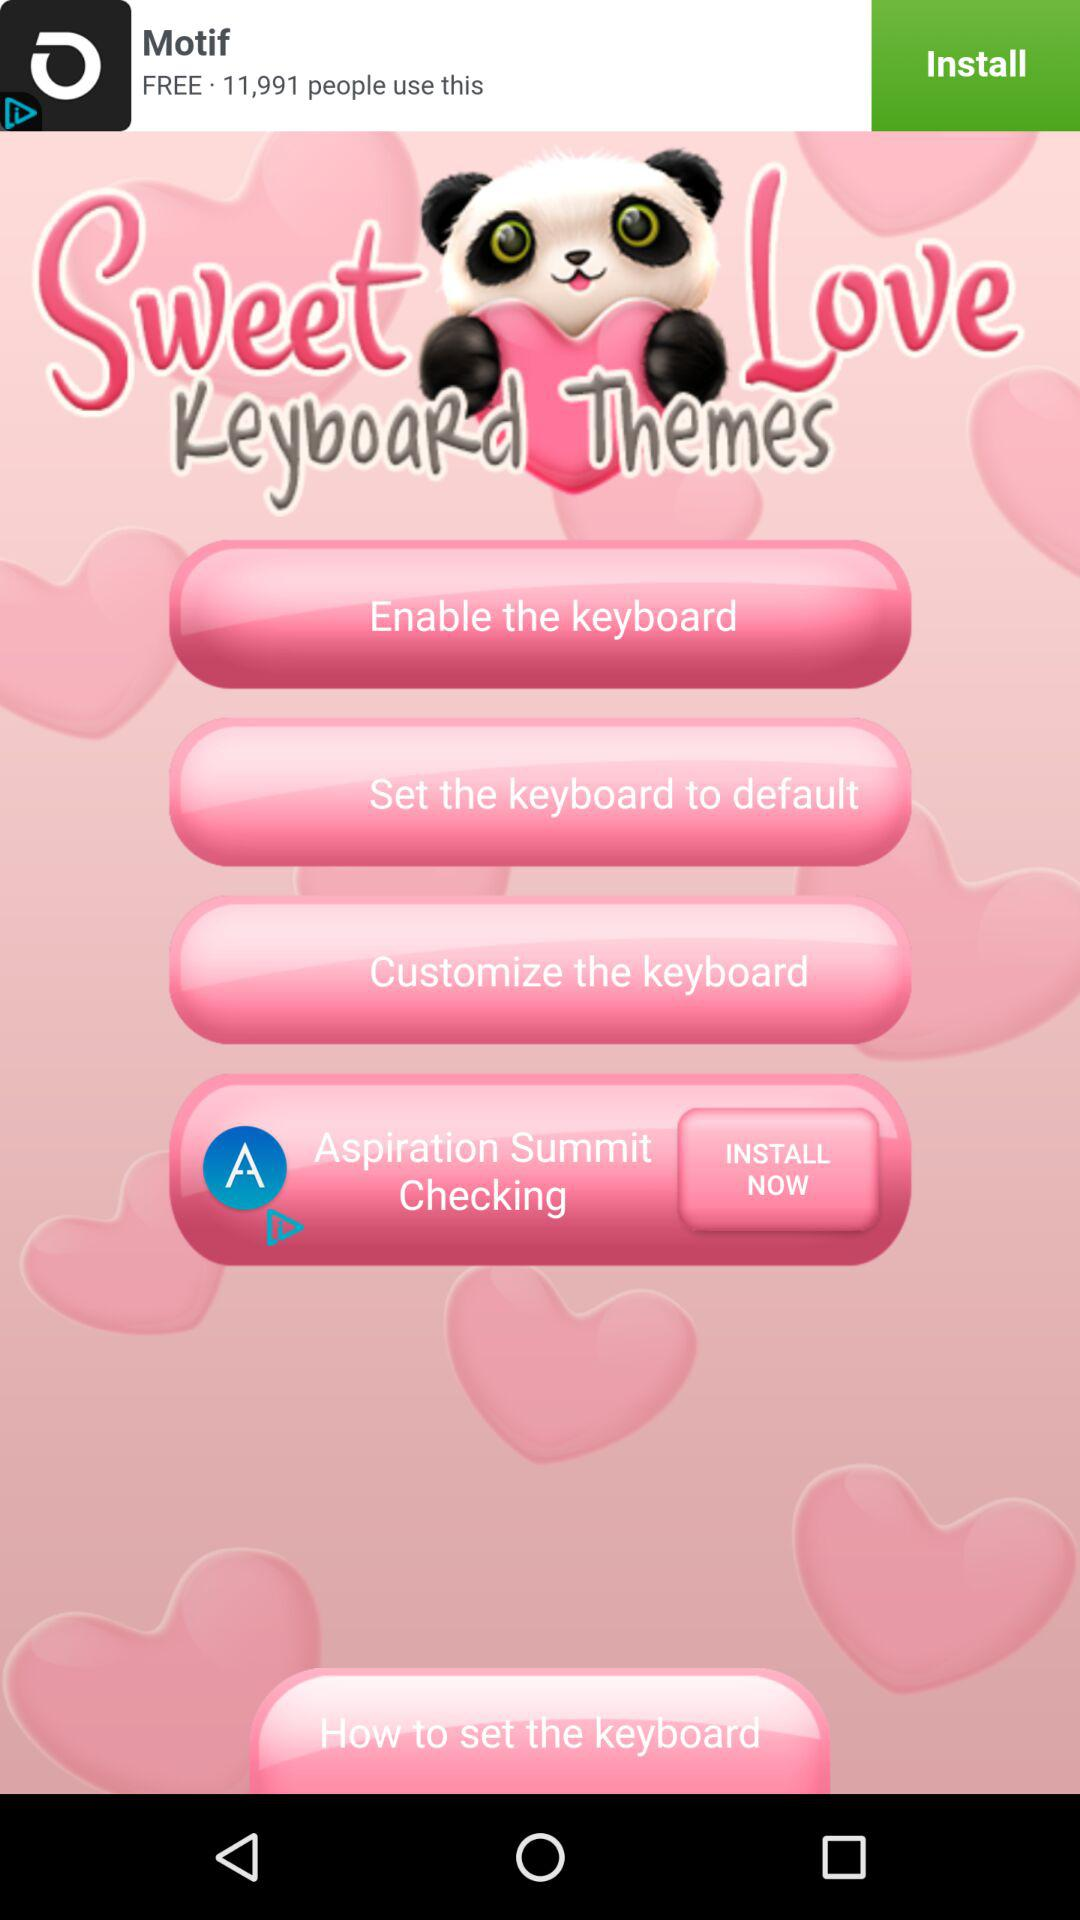What is the application name? The application name is "Sweet Love KeyboaRd Themes". 